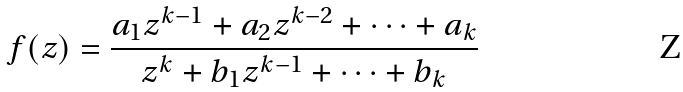<formula> <loc_0><loc_0><loc_500><loc_500>f ( z ) = \frac { a _ { 1 } z ^ { k - 1 } + a _ { 2 } z ^ { k - 2 } + \dots + a _ { k } } { z ^ { k } + b _ { 1 } z ^ { k - 1 } + \dots + b _ { k } }</formula> 